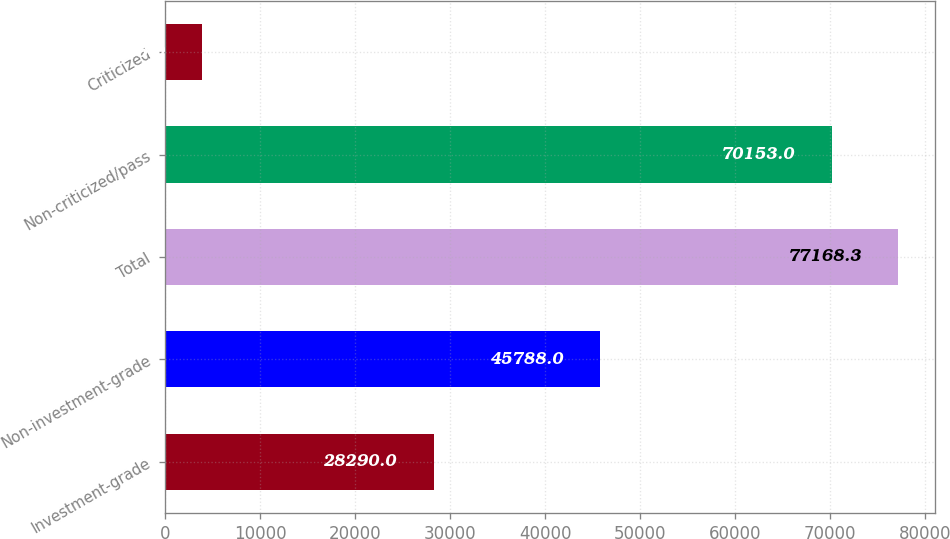Convert chart. <chart><loc_0><loc_0><loc_500><loc_500><bar_chart><fcel>Investment-grade<fcel>Non-investment-grade<fcel>Total<fcel>Non-criticized/pass<fcel>Criticized<nl><fcel>28290<fcel>45788<fcel>77168.3<fcel>70153<fcel>3925<nl></chart> 